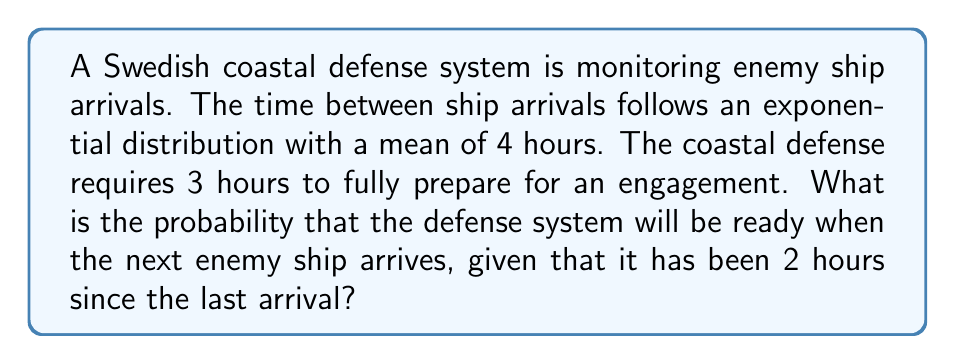Give your solution to this math problem. Let's approach this step-by-step:

1) The time between arrivals follows an exponential distribution with mean $\lambda^{-1} = 4$ hours. Therefore, $\lambda = \frac{1}{4}$ per hour.

2) We need to find $P(T > 3 | T > 2)$, where $T$ is the time until the next arrival.

3) Using the memoryless property of the exponential distribution:

   $P(T > 3 | T > 2) = P(T > 1)$

4) For an exponential distribution:

   $P(T > t) = e^{-\lambda t}$

5) Substituting our values:

   $P(T > 1) = e^{-\frac{1}{4} \cdot 1} = e^{-\frac{1}{4}}$

6) Calculate the final probability:

   $e^{-\frac{1}{4}} \approx 0.7788$

Therefore, the probability that the defense system will be ready is approximately 0.7788 or 77.88%.
Answer: $e^{-\frac{1}{4}} \approx 0.7788$ 